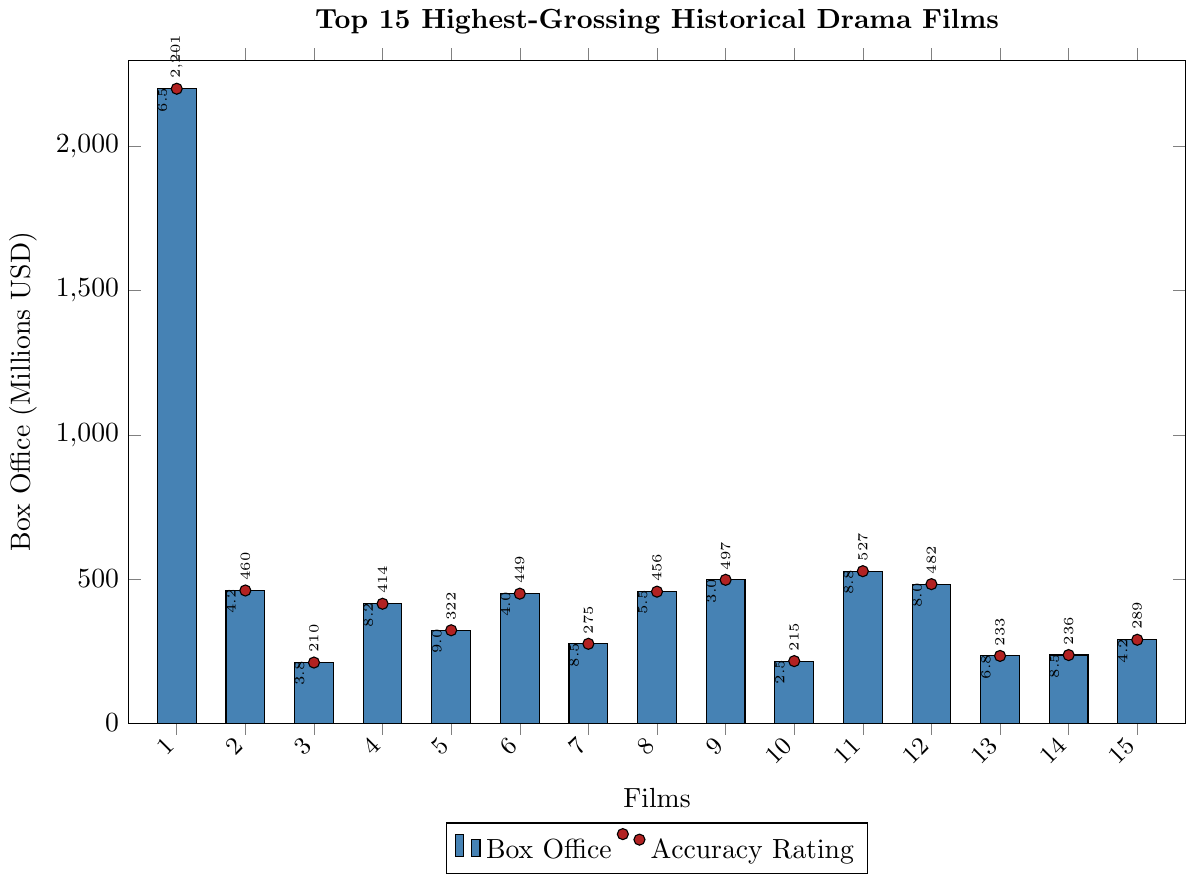Which film has the highest box office earnings? The film with the tallest blue bar represents the highest box office earnings. Based on the height of the bars, Titanic has the highest earnings.
Answer: Titanic Which film has the lowest accuracy rating? The film with the smallest red dot corresponding to the rating. By comparing the height of the red dots, The Patriot has the lowest rating.
Answer: The Patriot What is the total box office earnings for all films combined? Add up the heights of all the blue bars: 2201+460+210+414+322+449+275+456+497+215+527+482+233+236+289. The sum is the total box office earnings.
Answer: 6966 Which film has the highest accuracy rating and what is it? Find the red dot placed highest on the y-axis. By assessing the height of the red dots, Schindler's List has the highest accuracy rating of 9.0.
Answer: Schindler's List, 9.0 Identify the film that has both high box office earnings but a relatively low accuracy rating. Look for a blue bar that is relatively high and a corresponding red dot that is low. Troy meets this criterion with significant earnings and a low accuracy rating of 3.0.
Answer: Troy What's the average accuracy rating of all the films? Add all the accuracy ratings and divide by the number of films: (6.5+4.2+3.8+8.2+9.0+4.0+8.5+5.5+3.0+2.5+8.8+8.0+6.8+8.5+4.2)/15. The sum is 91.5, and the average rating is 91.5/15 = 6.1.
Answer: 6.1 Compare the box office earnings of Braveheart and Lincoln. Which one earned more? Assess the height of the blue bars for both Braveheart and Lincoln. Braveheart's bar is shorter than Lincoln's. Lincoln earned more.
Answer: Lincoln Which film has an accuracy rating of 8.2 and what are its box office earnings? Locate the red dot with a rating of 8.2 and find the corresponding blue bar. The King's Speech has an accuracy rating of 8.2 and earnings of 414 million USD.
Answer: The King's Speech, 414 What is the difference in box office earnings between Dunkirk and The Imitation Game? Find the heights of the blue bars for Dunkirk and The Imitation Game, then subtract the smaller (233) from the larger (527). The difference is 527 - 233 = 294.
Answer: 294 